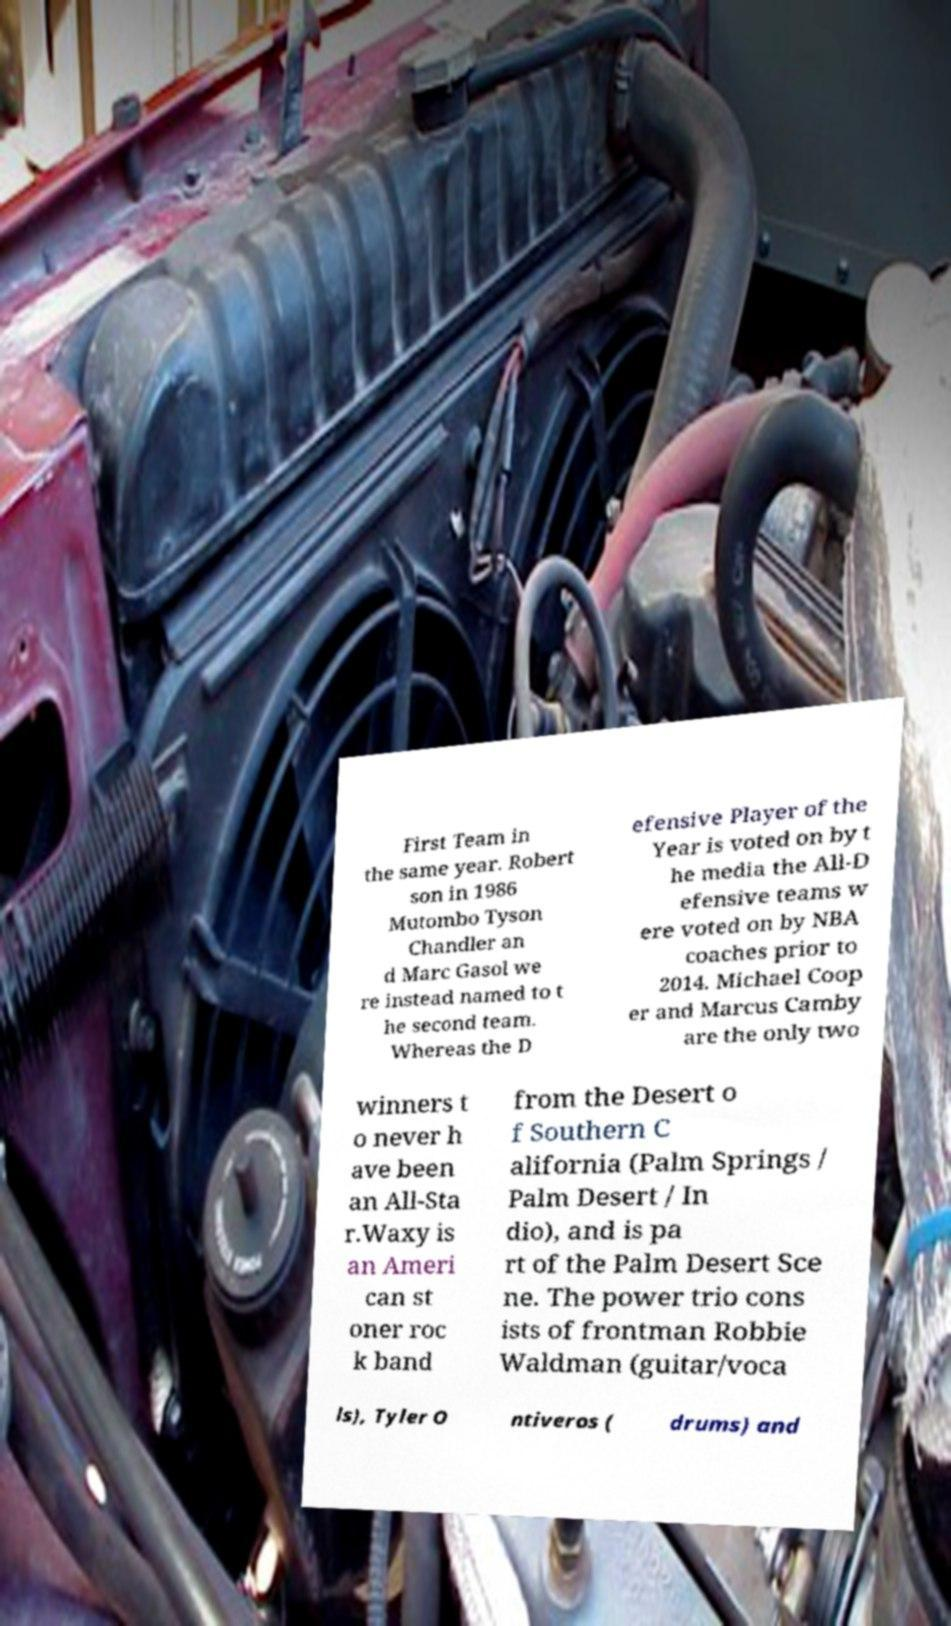Could you assist in decoding the text presented in this image and type it out clearly? First Team in the same year. Robert son in 1986 Mutombo Tyson Chandler an d Marc Gasol we re instead named to t he second team. Whereas the D efensive Player of the Year is voted on by t he media the All-D efensive teams w ere voted on by NBA coaches prior to 2014. Michael Coop er and Marcus Camby are the only two winners t o never h ave been an All-Sta r.Waxy is an Ameri can st oner roc k band from the Desert o f Southern C alifornia (Palm Springs / Palm Desert / In dio), and is pa rt of the Palm Desert Sce ne. The power trio cons ists of frontman Robbie Waldman (guitar/voca ls), Tyler O ntiveros ( drums) and 